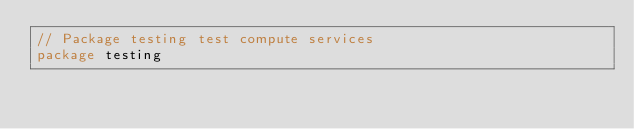Convert code to text. <code><loc_0><loc_0><loc_500><loc_500><_Go_>// Package testing test compute services
package testing
</code> 